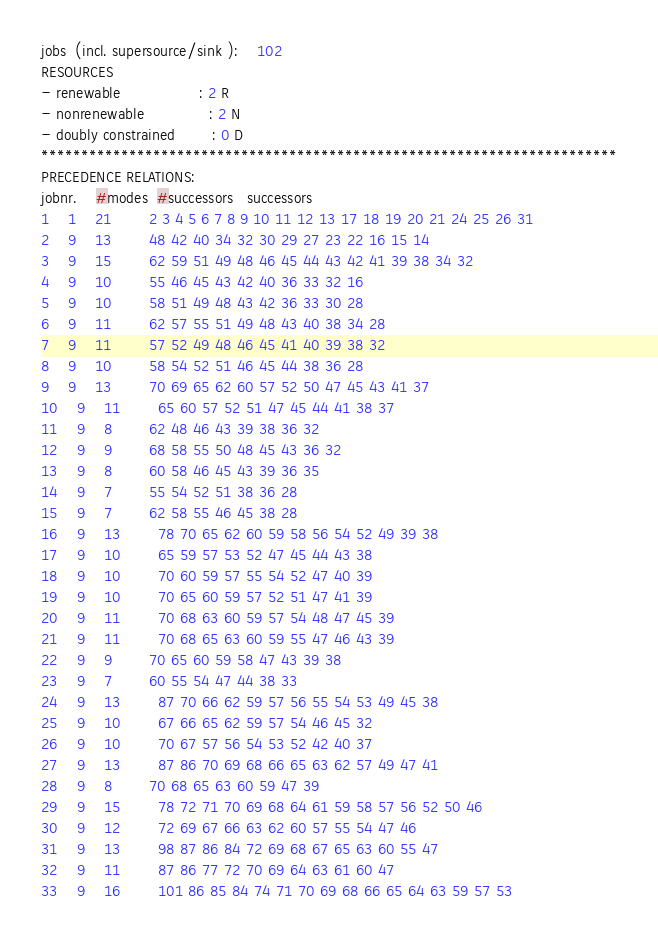Convert code to text. <code><loc_0><loc_0><loc_500><loc_500><_ObjectiveC_>jobs  (incl. supersource/sink ):	102
RESOURCES
- renewable                 : 2 R
- nonrenewable              : 2 N
- doubly constrained        : 0 D
************************************************************************
PRECEDENCE RELATIONS:
jobnr.    #modes  #successors   successors
1	1	21		2 3 4 5 6 7 8 9 10 11 12 13 17 18 19 20 21 24 25 26 31 
2	9	13		48 42 40 34 32 30 29 27 23 22 16 15 14 
3	9	15		62 59 51 49 48 46 45 44 43 42 41 39 38 34 32 
4	9	10		55 46 45 43 42 40 36 33 32 16 
5	9	10		58 51 49 48 43 42 36 33 30 28 
6	9	11		62 57 55 51 49 48 43 40 38 34 28 
7	9	11		57 52 49 48 46 45 41 40 39 38 32 
8	9	10		58 54 52 51 46 45 44 38 36 28 
9	9	13		70 69 65 62 60 57 52 50 47 45 43 41 37 
10	9	11		65 60 57 52 51 47 45 44 41 38 37 
11	9	8		62 48 46 43 39 38 36 32 
12	9	9		68 58 55 50 48 45 43 36 32 
13	9	8		60 58 46 45 43 39 36 35 
14	9	7		55 54 52 51 38 36 28 
15	9	7		62 58 55 46 45 38 28 
16	9	13		78 70 65 62 60 59 58 56 54 52 49 39 38 
17	9	10		65 59 57 53 52 47 45 44 43 38 
18	9	10		70 60 59 57 55 54 52 47 40 39 
19	9	10		70 65 60 59 57 52 51 47 41 39 
20	9	11		70 68 63 60 59 57 54 48 47 45 39 
21	9	11		70 68 65 63 60 59 55 47 46 43 39 
22	9	9		70 65 60 59 58 47 43 39 38 
23	9	7		60 55 54 47 44 38 33 
24	9	13		87 70 66 62 59 57 56 55 54 53 49 45 38 
25	9	10		67 66 65 62 59 57 54 46 45 32 
26	9	10		70 67 57 56 54 53 52 42 40 37 
27	9	13		87 86 70 69 68 66 65 63 62 57 49 47 41 
28	9	8		70 68 65 63 60 59 47 39 
29	9	15		78 72 71 70 69 68 64 61 59 58 57 56 52 50 46 
30	9	12		72 69 67 66 63 62 60 57 55 54 47 46 
31	9	13		98 87 86 84 72 69 68 67 65 63 60 55 47 
32	9	11		87 86 77 72 70 69 64 63 61 60 47 
33	9	16		101 86 85 84 74 71 70 69 68 66 65 64 63 59 57 53 </code> 